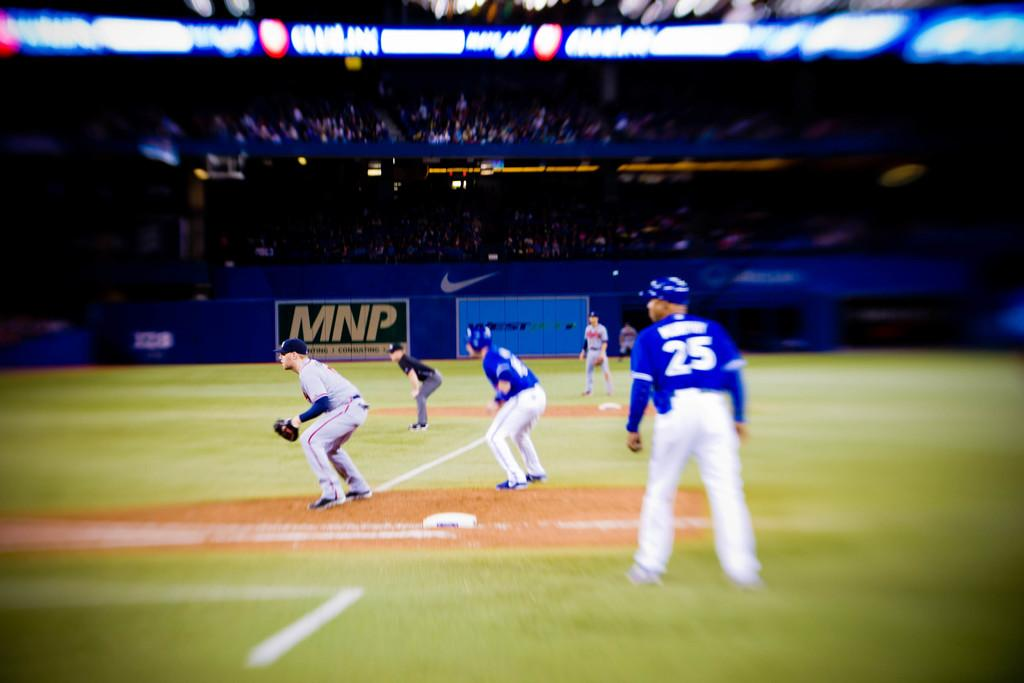Provide a one-sentence caption for the provided image. Baseball players on the field with an advertising sign in the background for MNP. 